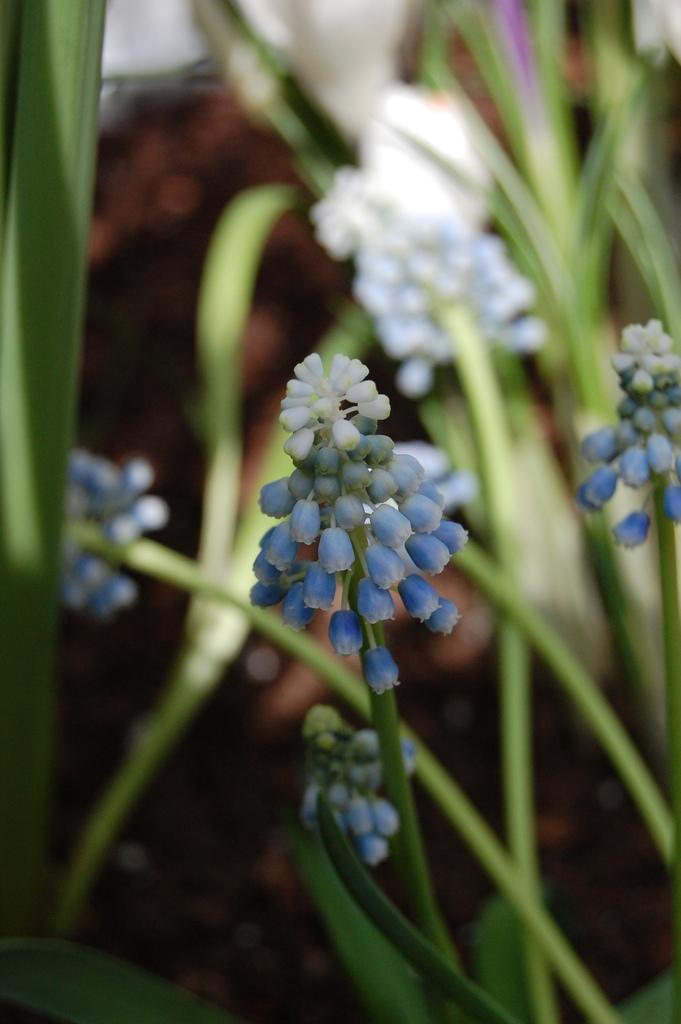What type of living organisms can be seen in the image? Plants can be seen in the image. What are the plants displaying? There are flowers on the plants. Reasoning: Let's think step by step by step in order to produce the conversation. We start by identifying the main subject in the image, which is the plants. Then, we expand the conversation to include the specific feature of the plants, which are the flowers. Each question is designed to elicit a specific detail about the image that is known from the provided facts. Absurd Question/Answer: What is the title of the book that the person is reading in the image? There is no book or person present in the image; it only features plants with flowers. 